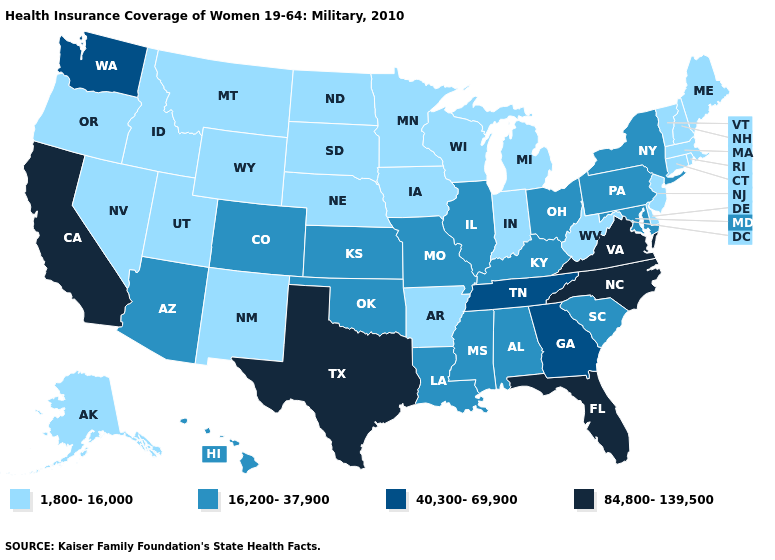What is the value of Idaho?
Concise answer only. 1,800-16,000. Does Rhode Island have the lowest value in the USA?
Concise answer only. Yes. Does Idaho have the highest value in the USA?
Write a very short answer. No. Does Connecticut have a lower value than Utah?
Be succinct. No. Does Ohio have the lowest value in the USA?
Give a very brief answer. No. What is the value of Nebraska?
Give a very brief answer. 1,800-16,000. What is the highest value in the MidWest ?
Answer briefly. 16,200-37,900. Name the states that have a value in the range 16,200-37,900?
Quick response, please. Alabama, Arizona, Colorado, Hawaii, Illinois, Kansas, Kentucky, Louisiana, Maryland, Mississippi, Missouri, New York, Ohio, Oklahoma, Pennsylvania, South Carolina. What is the value of Oregon?
Quick response, please. 1,800-16,000. What is the lowest value in states that border Nevada?
Short answer required. 1,800-16,000. How many symbols are there in the legend?
Keep it brief. 4. Name the states that have a value in the range 16,200-37,900?
Be succinct. Alabama, Arizona, Colorado, Hawaii, Illinois, Kansas, Kentucky, Louisiana, Maryland, Mississippi, Missouri, New York, Ohio, Oklahoma, Pennsylvania, South Carolina. What is the value of Oklahoma?
Write a very short answer. 16,200-37,900. Which states have the lowest value in the USA?
Answer briefly. Alaska, Arkansas, Connecticut, Delaware, Idaho, Indiana, Iowa, Maine, Massachusetts, Michigan, Minnesota, Montana, Nebraska, Nevada, New Hampshire, New Jersey, New Mexico, North Dakota, Oregon, Rhode Island, South Dakota, Utah, Vermont, West Virginia, Wisconsin, Wyoming. Name the states that have a value in the range 1,800-16,000?
Keep it brief. Alaska, Arkansas, Connecticut, Delaware, Idaho, Indiana, Iowa, Maine, Massachusetts, Michigan, Minnesota, Montana, Nebraska, Nevada, New Hampshire, New Jersey, New Mexico, North Dakota, Oregon, Rhode Island, South Dakota, Utah, Vermont, West Virginia, Wisconsin, Wyoming. 